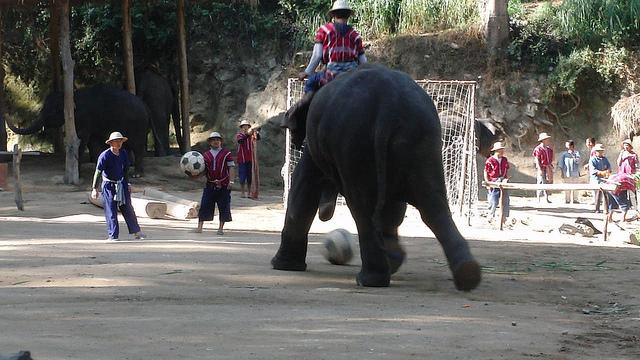What game is the elephant playing with the people?
Be succinct. Soccer. What is the man riding?
Write a very short answer. Elephant. What animals are here?
Write a very short answer. Elephant. How many people are there?
Be succinct. 10. Is the ball in the air?
Concise answer only. No. How many elephants have riders on them?
Be succinct. 1. What animal is in the photo?
Keep it brief. Elephant. 